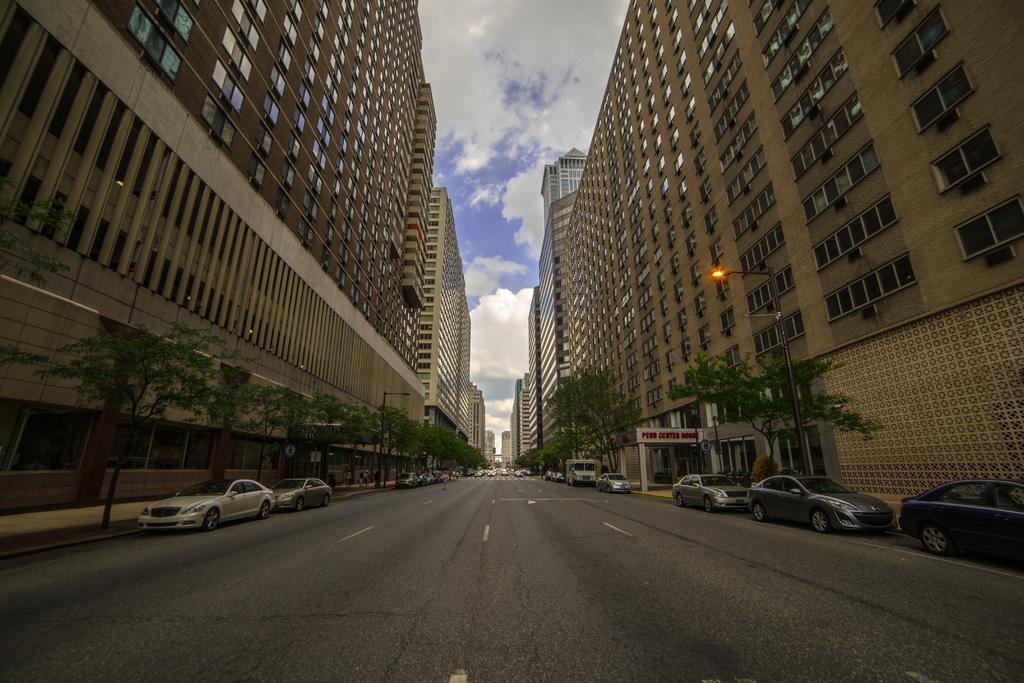In one or two sentences, can you explain what this image depicts? In this picture I can observe a road in the middle of the picture. On either sides of the road I can observe cars, plants and buildings. In the background I can observe some clouds in the sky. 